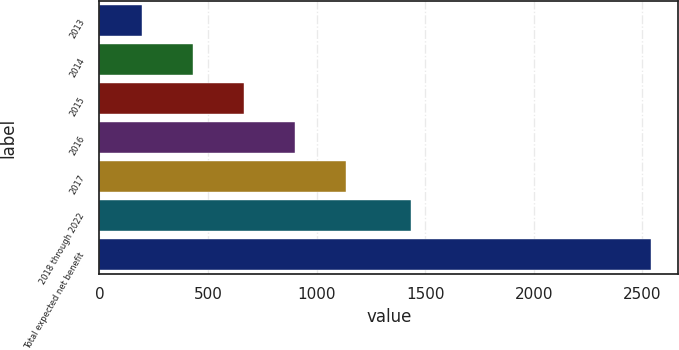<chart> <loc_0><loc_0><loc_500><loc_500><bar_chart><fcel>2013<fcel>2014<fcel>2015<fcel>2016<fcel>2017<fcel>2018 through 2022<fcel>Total expected net benefit<nl><fcel>197<fcel>431.1<fcel>665.2<fcel>899.3<fcel>1133.4<fcel>1434<fcel>2538<nl></chart> 